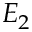Convert formula to latex. <formula><loc_0><loc_0><loc_500><loc_500>E _ { 2 }</formula> 